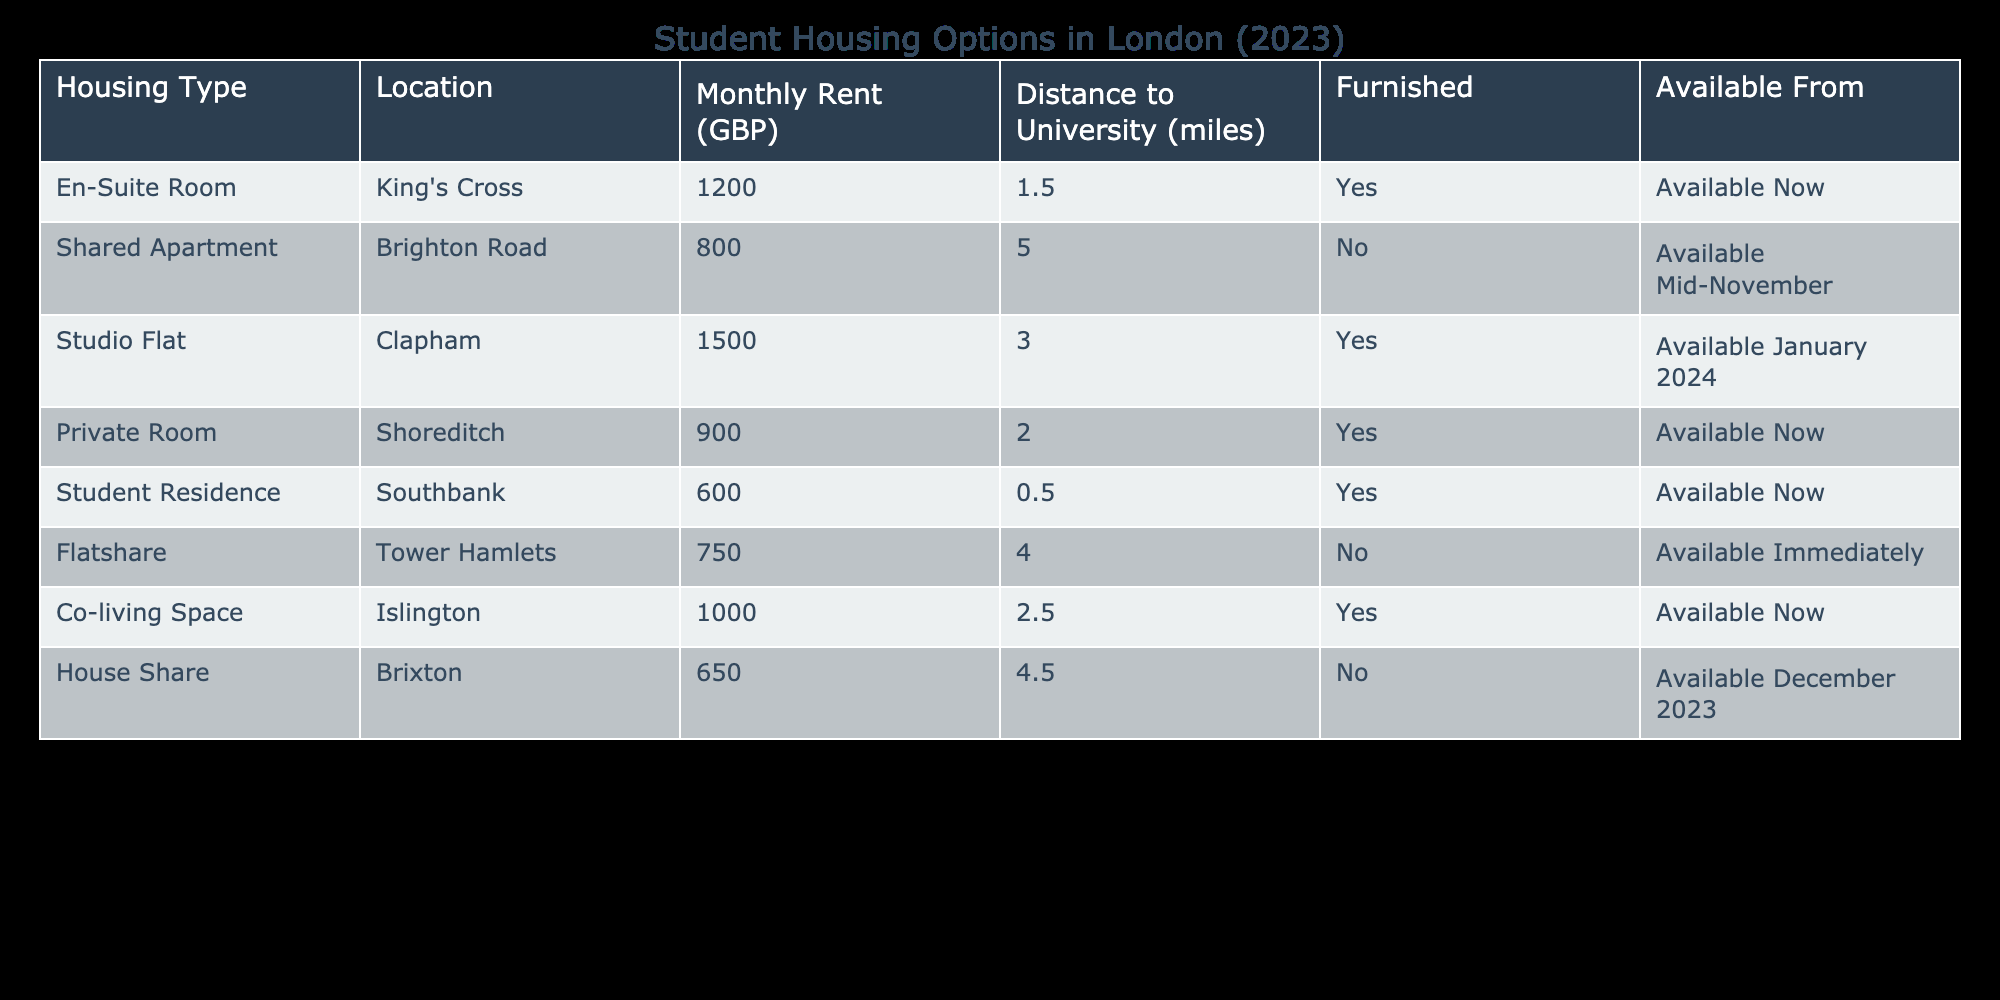What is the cheapest housing option listed in the table? By examining the "Monthly Rent (GBP)" column, we find that the least expensive option is the Student Residence in Southbank, which costs 600 GBP.
Answer: 600 GBP How many housing options are available to move into immediately? Checking the "Available From" column, the options available immediately are: Private Room, Flatshare, and Co-living Space, which totals to three available options.
Answer: 3 Which location offers the most expensive housing type? Looking at the "Monthly Rent (GBP)" column, the Studio Flat in Clapham has the highest rent at 1500 GBP, making it the most expensive option in the list.
Answer: Clapham Is there any housing option that is furnished and available now? From the "Furnished" column, the choices that are furnished and have the "Available From" status of "Available Now" include: En-Suite Room, Private Room, Student Residence, and Co-living Space, indicating there are indeed furnished options available now.
Answer: Yes What is the average distance to the university for all housing options? Calculate the average distance: (1.5 + 5.0 + 3.0 + 2.0 + 0.5 + 4.0 + 2.5 + 4.5) = 23, and there are 8 options, so 23/8 = 2.875 miles. Thus, the average distance to the university is approximately 2.88 miles.
Answer: 2.88 miles How many of the available housing options have a distance of more than 3 miles from the university? Filtering through the "Distance to University (miles)" column, we count options that exceed 3 miles: Brighton Road, Tower Hamlets, and Brixton, totaling three options falling under this category.
Answer: 3 Is there any private room available with a distance to the university below 2 miles? The Private Room option located in Shoreditch is available and has a distance of 2.0 miles to the university, which means it does not fall below 2 miles, hence there are no private rooms available within the specified distance.
Answer: No What is the total monthly rent of all housing options combined? To find the total rent, we sum up all the values in the "Monthly Rent (GBP)" column: 1200 + 800 + 1500 + 900 + 600 + 750 + 1000 + 650 = 5900 GBP.
Answer: 5900 GBP 